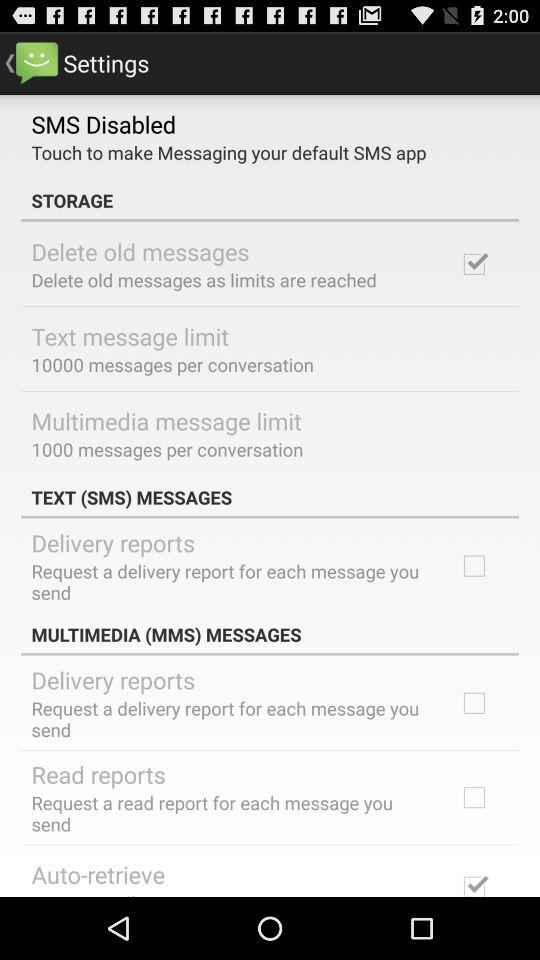What is the current status of "Auto-retrieve"? The current status of "Auto-retrieve" is "on". 